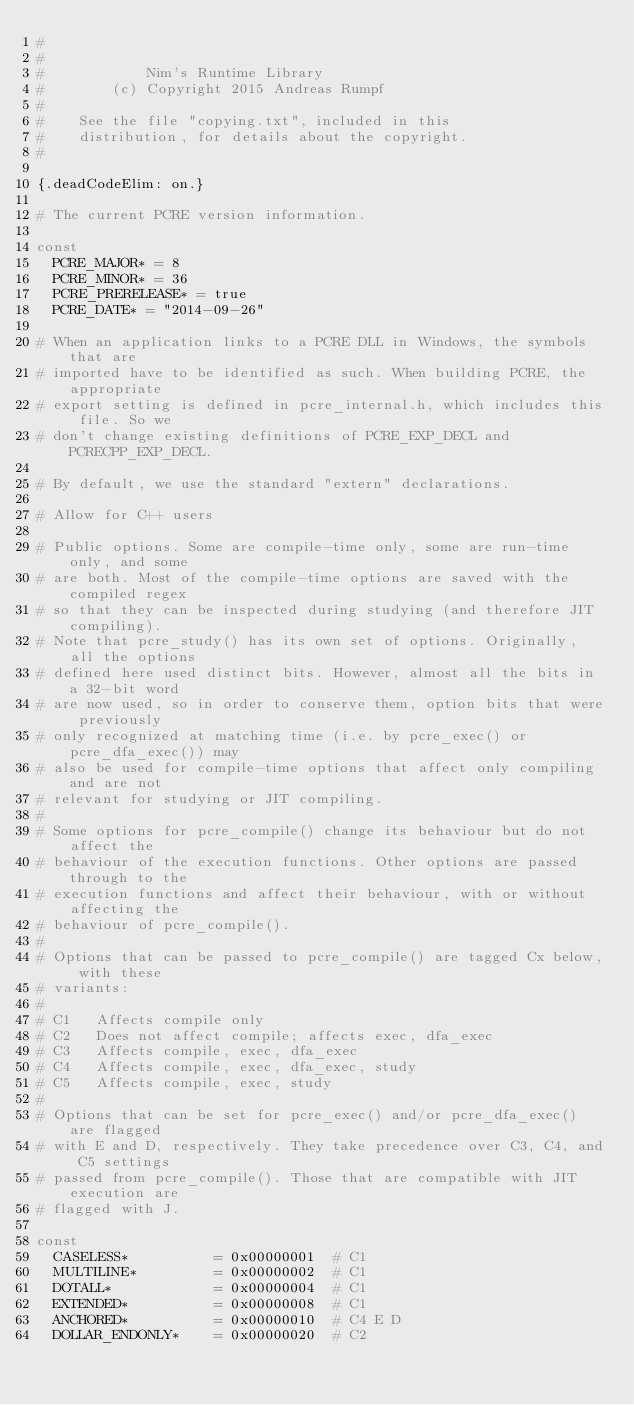Convert code to text. <code><loc_0><loc_0><loc_500><loc_500><_Nim_>#
#
#            Nim's Runtime Library
#        (c) Copyright 2015 Andreas Rumpf
#
#    See the file "copying.txt", included in this
#    distribution, for details about the copyright.
#

{.deadCodeElim: on.}

# The current PCRE version information.

const
  PCRE_MAJOR* = 8
  PCRE_MINOR* = 36
  PCRE_PRERELEASE* = true
  PCRE_DATE* = "2014-09-26"

# When an application links to a PCRE DLL in Windows, the symbols that are
# imported have to be identified as such. When building PCRE, the appropriate
# export setting is defined in pcre_internal.h, which includes this file. So we
# don't change existing definitions of PCRE_EXP_DECL and PCRECPP_EXP_DECL.

# By default, we use the standard "extern" declarations.

# Allow for C++ users

# Public options. Some are compile-time only, some are run-time only, and some
# are both. Most of the compile-time options are saved with the compiled regex
# so that they can be inspected during studying (and therefore JIT compiling).
# Note that pcre_study() has its own set of options. Originally, all the options
# defined here used distinct bits. However, almost all the bits in a 32-bit word
# are now used, so in order to conserve them, option bits that were previously
# only recognized at matching time (i.e. by pcre_exec() or pcre_dfa_exec()) may
# also be used for compile-time options that affect only compiling and are not
# relevant for studying or JIT compiling.
#
# Some options for pcre_compile() change its behaviour but do not affect the
# behaviour of the execution functions. Other options are passed through to the
# execution functions and affect their behaviour, with or without affecting the
# behaviour of pcre_compile().
#
# Options that can be passed to pcre_compile() are tagged Cx below, with these
# variants:
#
# C1   Affects compile only
# C2   Does not affect compile; affects exec, dfa_exec
# C3   Affects compile, exec, dfa_exec
# C4   Affects compile, exec, dfa_exec, study
# C5   Affects compile, exec, study
#
# Options that can be set for pcre_exec() and/or pcre_dfa_exec() are flagged
# with E and D, respectively. They take precedence over C3, C4, and C5 settings
# passed from pcre_compile(). Those that are compatible with JIT execution are
# flagged with J.

const
  CASELESS*          = 0x00000001  # C1
  MULTILINE*         = 0x00000002  # C1
  DOTALL*            = 0x00000004  # C1
  EXTENDED*          = 0x00000008  # C1
  ANCHORED*          = 0x00000010  # C4 E D
  DOLLAR_ENDONLY*    = 0x00000020  # C2</code> 